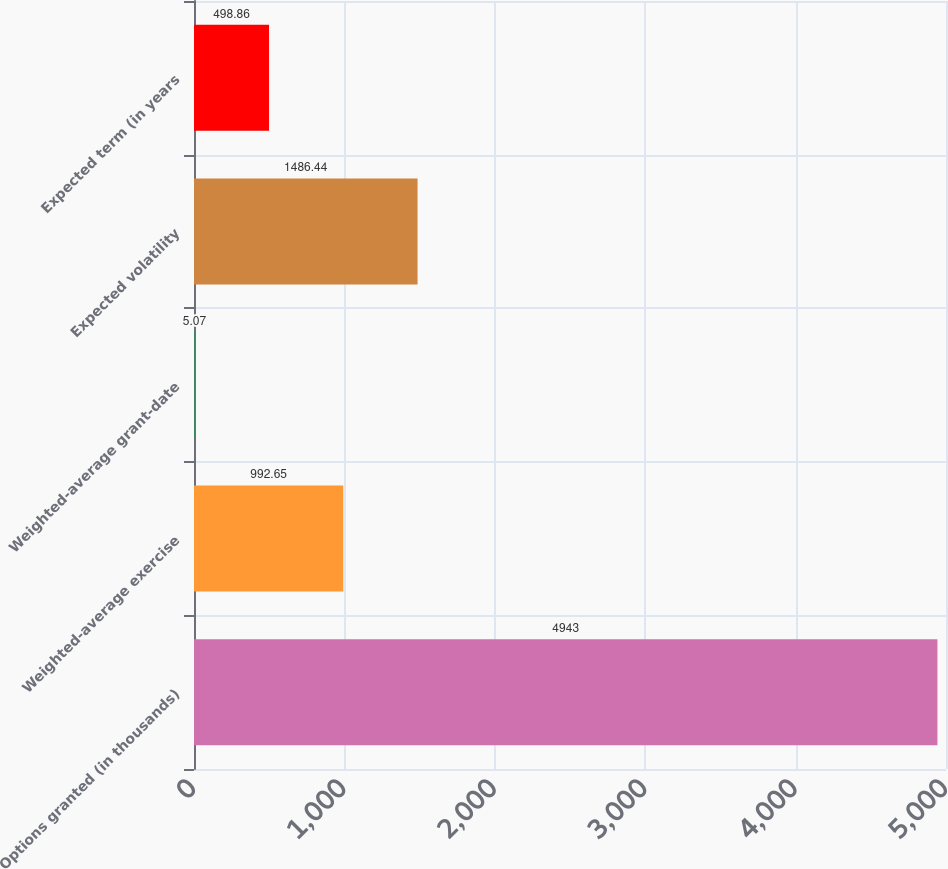Convert chart to OTSL. <chart><loc_0><loc_0><loc_500><loc_500><bar_chart><fcel>Options granted (in thousands)<fcel>Weighted-average exercise<fcel>Weighted-average grant-date<fcel>Expected volatility<fcel>Expected term (in years<nl><fcel>4943<fcel>992.65<fcel>5.07<fcel>1486.44<fcel>498.86<nl></chart> 